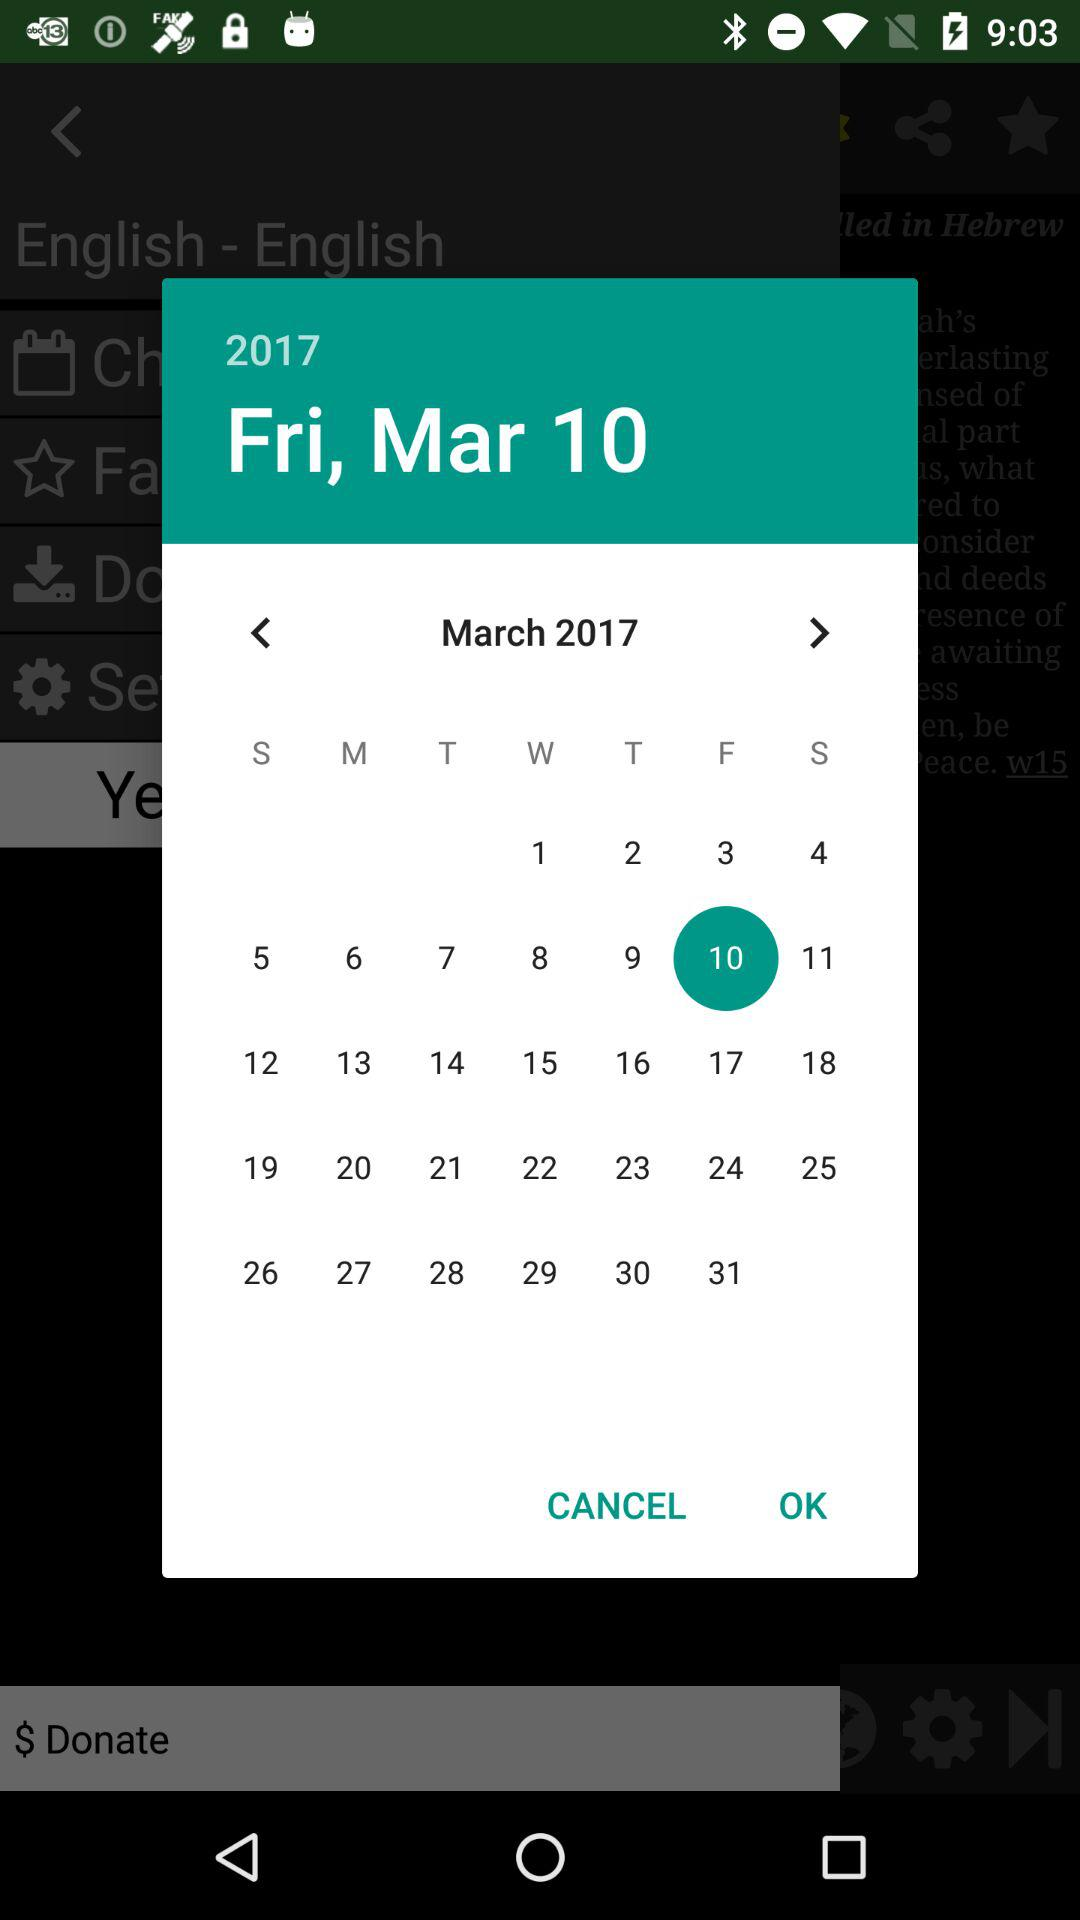What's the selected date? The selected date is Friday, March 10, 2017. 